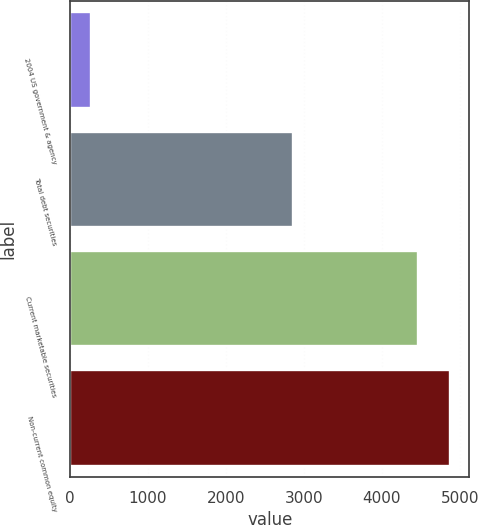Convert chart to OTSL. <chart><loc_0><loc_0><loc_500><loc_500><bar_chart><fcel>2004 US government & agency<fcel>Total debt securities<fcel>Current marketable securities<fcel>Non-current common equity<nl><fcel>269<fcel>2857<fcel>4458<fcel>4876.9<nl></chart> 